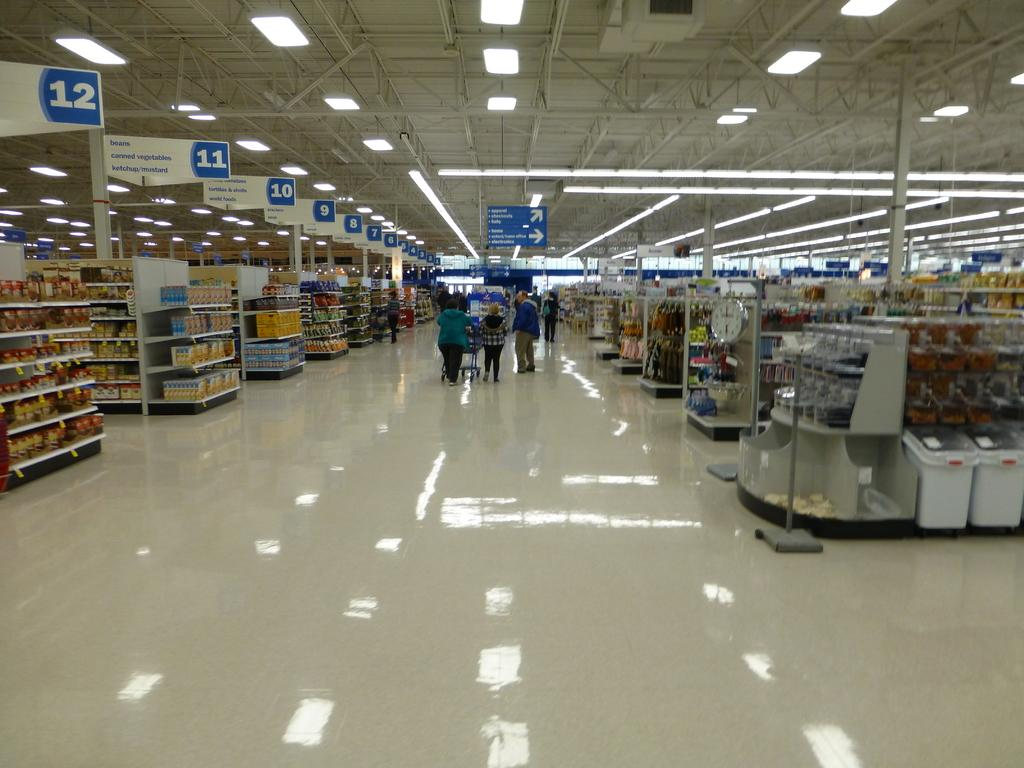<image>
Present a compact description of the photo's key features. a walmart with the aisles numbered in order up to 12. 